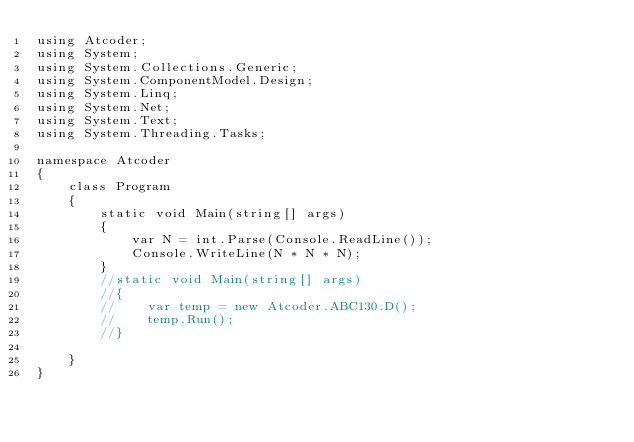Convert code to text. <code><loc_0><loc_0><loc_500><loc_500><_C#_>using Atcoder;
using System;
using System.Collections.Generic;
using System.ComponentModel.Design;
using System.Linq;
using System.Net;
using System.Text;
using System.Threading.Tasks;

namespace Atcoder
{
    class Program
    {
        static void Main(string[] args)
        {
            var N = int.Parse(Console.ReadLine());
            Console.WriteLine(N * N * N);
        }
        //static void Main(string[] args)
        //{
        //    var temp = new Atcoder.ABC130.D();
        //    temp.Run();
        //}

    }
}</code> 